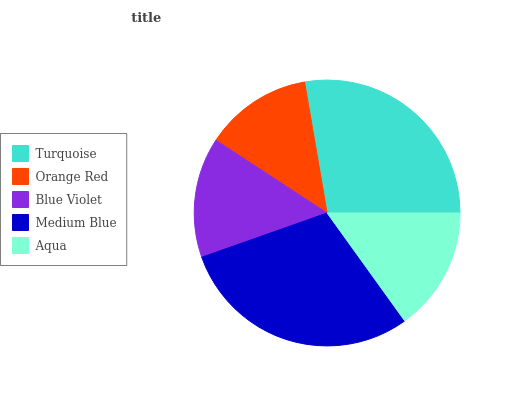Is Orange Red the minimum?
Answer yes or no. Yes. Is Medium Blue the maximum?
Answer yes or no. Yes. Is Blue Violet the minimum?
Answer yes or no. No. Is Blue Violet the maximum?
Answer yes or no. No. Is Blue Violet greater than Orange Red?
Answer yes or no. Yes. Is Orange Red less than Blue Violet?
Answer yes or no. Yes. Is Orange Red greater than Blue Violet?
Answer yes or no. No. Is Blue Violet less than Orange Red?
Answer yes or no. No. Is Aqua the high median?
Answer yes or no. Yes. Is Aqua the low median?
Answer yes or no. Yes. Is Blue Violet the high median?
Answer yes or no. No. Is Orange Red the low median?
Answer yes or no. No. 